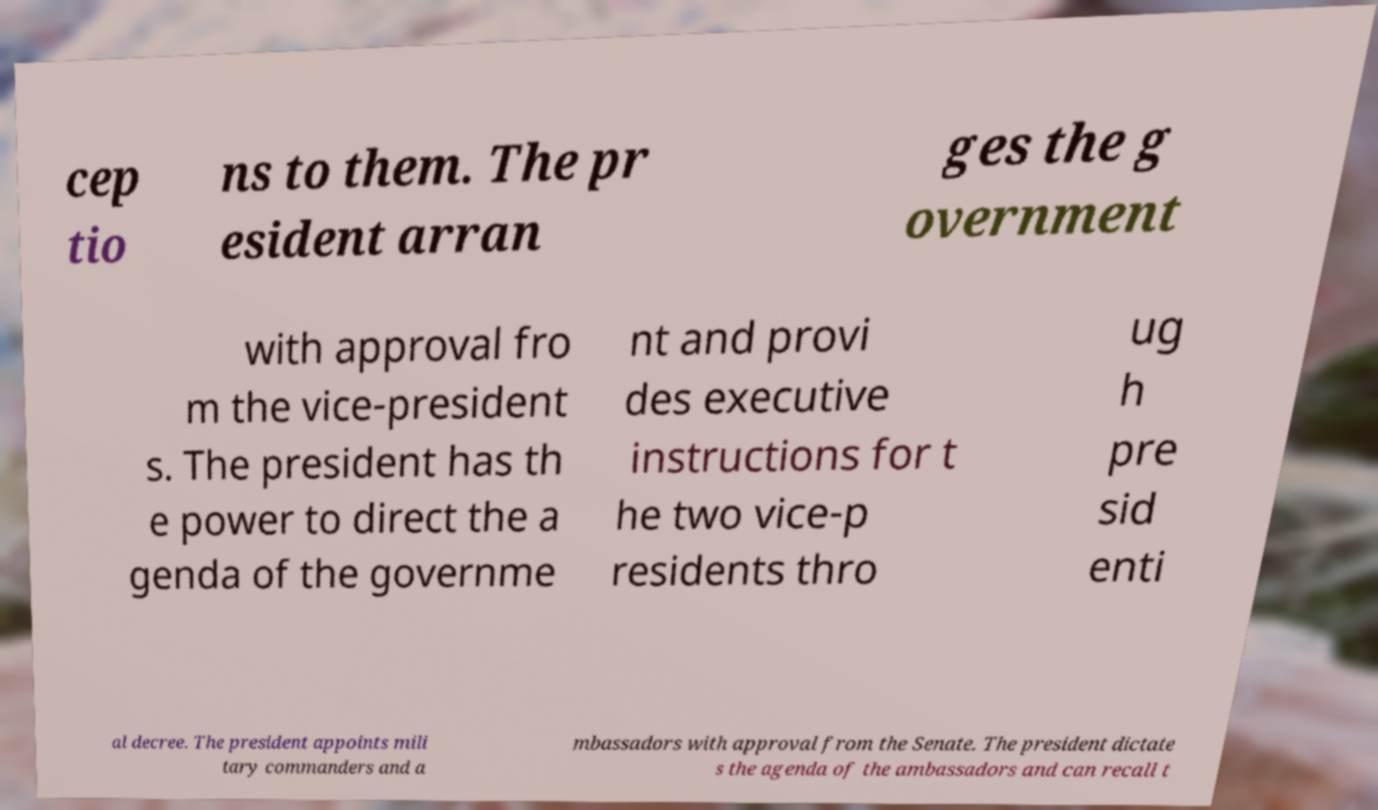I need the written content from this picture converted into text. Can you do that? cep tio ns to them. The pr esident arran ges the g overnment with approval fro m the vice-president s. The president has th e power to direct the a genda of the governme nt and provi des executive instructions for t he two vice-p residents thro ug h pre sid enti al decree. The president appoints mili tary commanders and a mbassadors with approval from the Senate. The president dictate s the agenda of the ambassadors and can recall t 